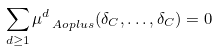Convert formula to latex. <formula><loc_0><loc_0><loc_500><loc_500>\sum _ { d \geq 1 } \mu _ { \ A o p l u s } ^ { d } ( \delta _ { C } , \dots , \delta _ { C } ) = 0</formula> 